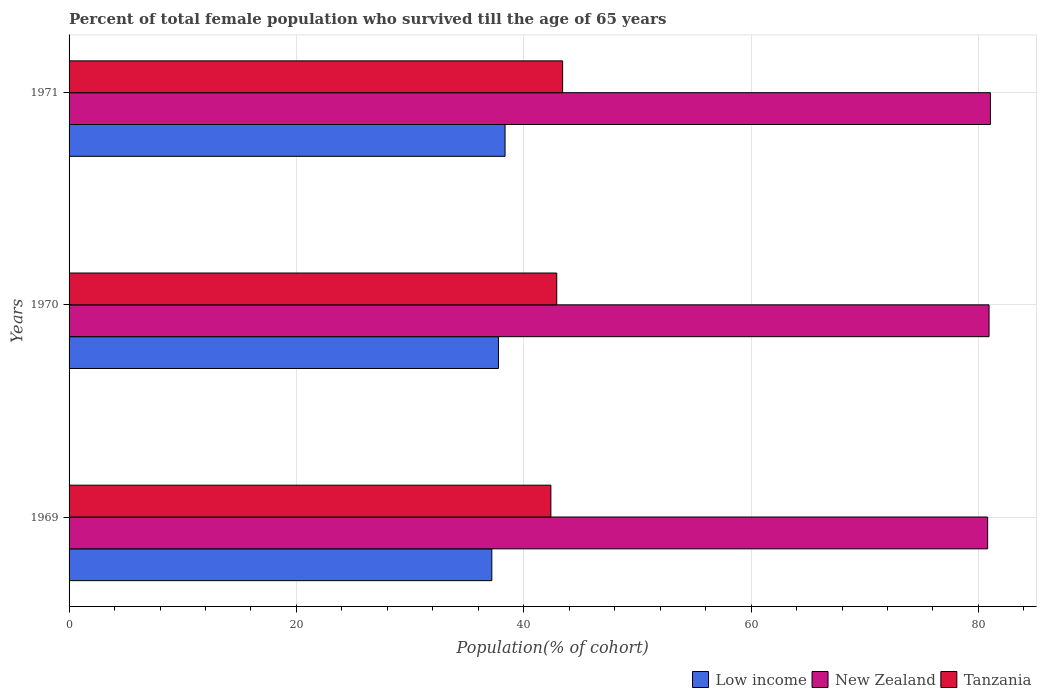How many different coloured bars are there?
Provide a short and direct response. 3. How many groups of bars are there?
Make the answer very short. 3. Are the number of bars per tick equal to the number of legend labels?
Give a very brief answer. Yes. Are the number of bars on each tick of the Y-axis equal?
Offer a terse response. Yes. In how many cases, is the number of bars for a given year not equal to the number of legend labels?
Offer a terse response. 0. What is the percentage of total female population who survived till the age of 65 years in New Zealand in 1969?
Provide a short and direct response. 80.81. Across all years, what is the maximum percentage of total female population who survived till the age of 65 years in Tanzania?
Your response must be concise. 43.42. Across all years, what is the minimum percentage of total female population who survived till the age of 65 years in New Zealand?
Ensure brevity in your answer.  80.81. In which year was the percentage of total female population who survived till the age of 65 years in Low income minimum?
Provide a succinct answer. 1969. What is the total percentage of total female population who survived till the age of 65 years in New Zealand in the graph?
Offer a very short reply. 242.79. What is the difference between the percentage of total female population who survived till the age of 65 years in Low income in 1969 and that in 1970?
Keep it short and to the point. -0.58. What is the difference between the percentage of total female population who survived till the age of 65 years in Tanzania in 1971 and the percentage of total female population who survived till the age of 65 years in New Zealand in 1970?
Your answer should be compact. -37.51. What is the average percentage of total female population who survived till the age of 65 years in Tanzania per year?
Give a very brief answer. 42.9. In the year 1969, what is the difference between the percentage of total female population who survived till the age of 65 years in New Zealand and percentage of total female population who survived till the age of 65 years in Tanzania?
Make the answer very short. 38.43. What is the ratio of the percentage of total female population who survived till the age of 65 years in Low income in 1969 to that in 1971?
Keep it short and to the point. 0.97. Is the percentage of total female population who survived till the age of 65 years in Tanzania in 1970 less than that in 1971?
Keep it short and to the point. Yes. Is the difference between the percentage of total female population who survived till the age of 65 years in New Zealand in 1969 and 1970 greater than the difference between the percentage of total female population who survived till the age of 65 years in Tanzania in 1969 and 1970?
Provide a short and direct response. Yes. What is the difference between the highest and the second highest percentage of total female population who survived till the age of 65 years in New Zealand?
Make the answer very short. 0.12. What is the difference between the highest and the lowest percentage of total female population who survived till the age of 65 years in New Zealand?
Provide a short and direct response. 0.24. Is the sum of the percentage of total female population who survived till the age of 65 years in Low income in 1969 and 1970 greater than the maximum percentage of total female population who survived till the age of 65 years in New Zealand across all years?
Make the answer very short. No. What does the 2nd bar from the top in 1969 represents?
Offer a very short reply. New Zealand. What does the 1st bar from the bottom in 1970 represents?
Keep it short and to the point. Low income. Is it the case that in every year, the sum of the percentage of total female population who survived till the age of 65 years in New Zealand and percentage of total female population who survived till the age of 65 years in Low income is greater than the percentage of total female population who survived till the age of 65 years in Tanzania?
Provide a succinct answer. Yes. How many bars are there?
Your response must be concise. 9. Are all the bars in the graph horizontal?
Provide a succinct answer. Yes. How are the legend labels stacked?
Your answer should be very brief. Horizontal. What is the title of the graph?
Your answer should be very brief. Percent of total female population who survived till the age of 65 years. What is the label or title of the X-axis?
Offer a very short reply. Population(% of cohort). What is the label or title of the Y-axis?
Provide a short and direct response. Years. What is the Population(% of cohort) in Low income in 1969?
Ensure brevity in your answer.  37.19. What is the Population(% of cohort) in New Zealand in 1969?
Provide a succinct answer. 80.81. What is the Population(% of cohort) in Tanzania in 1969?
Ensure brevity in your answer.  42.38. What is the Population(% of cohort) in Low income in 1970?
Give a very brief answer. 37.77. What is the Population(% of cohort) in New Zealand in 1970?
Provide a short and direct response. 80.93. What is the Population(% of cohort) in Tanzania in 1970?
Provide a short and direct response. 42.9. What is the Population(% of cohort) in Low income in 1971?
Your answer should be compact. 38.35. What is the Population(% of cohort) of New Zealand in 1971?
Make the answer very short. 81.05. What is the Population(% of cohort) in Tanzania in 1971?
Offer a terse response. 43.42. Across all years, what is the maximum Population(% of cohort) of Low income?
Give a very brief answer. 38.35. Across all years, what is the maximum Population(% of cohort) of New Zealand?
Your answer should be very brief. 81.05. Across all years, what is the maximum Population(% of cohort) of Tanzania?
Provide a succinct answer. 43.42. Across all years, what is the minimum Population(% of cohort) in Low income?
Your answer should be compact. 37.19. Across all years, what is the minimum Population(% of cohort) in New Zealand?
Your response must be concise. 80.81. Across all years, what is the minimum Population(% of cohort) in Tanzania?
Provide a succinct answer. 42.38. What is the total Population(% of cohort) of Low income in the graph?
Offer a terse response. 113.32. What is the total Population(% of cohort) of New Zealand in the graph?
Keep it short and to the point. 242.79. What is the total Population(% of cohort) of Tanzania in the graph?
Ensure brevity in your answer.  128.71. What is the difference between the Population(% of cohort) of Low income in 1969 and that in 1970?
Keep it short and to the point. -0.58. What is the difference between the Population(% of cohort) in New Zealand in 1969 and that in 1970?
Make the answer very short. -0.12. What is the difference between the Population(% of cohort) in Tanzania in 1969 and that in 1970?
Offer a very short reply. -0.52. What is the difference between the Population(% of cohort) in Low income in 1969 and that in 1971?
Your answer should be compact. -1.16. What is the difference between the Population(% of cohort) in New Zealand in 1969 and that in 1971?
Your answer should be compact. -0.24. What is the difference between the Population(% of cohort) of Tanzania in 1969 and that in 1971?
Provide a short and direct response. -1.03. What is the difference between the Population(% of cohort) of Low income in 1970 and that in 1971?
Keep it short and to the point. -0.58. What is the difference between the Population(% of cohort) in New Zealand in 1970 and that in 1971?
Provide a short and direct response. -0.12. What is the difference between the Population(% of cohort) in Tanzania in 1970 and that in 1971?
Offer a very short reply. -0.52. What is the difference between the Population(% of cohort) of Low income in 1969 and the Population(% of cohort) of New Zealand in 1970?
Your answer should be very brief. -43.74. What is the difference between the Population(% of cohort) of Low income in 1969 and the Population(% of cohort) of Tanzania in 1970?
Ensure brevity in your answer.  -5.71. What is the difference between the Population(% of cohort) of New Zealand in 1969 and the Population(% of cohort) of Tanzania in 1970?
Provide a short and direct response. 37.91. What is the difference between the Population(% of cohort) in Low income in 1969 and the Population(% of cohort) in New Zealand in 1971?
Provide a short and direct response. -43.86. What is the difference between the Population(% of cohort) in Low income in 1969 and the Population(% of cohort) in Tanzania in 1971?
Offer a terse response. -6.23. What is the difference between the Population(% of cohort) in New Zealand in 1969 and the Population(% of cohort) in Tanzania in 1971?
Make the answer very short. 37.39. What is the difference between the Population(% of cohort) in Low income in 1970 and the Population(% of cohort) in New Zealand in 1971?
Your answer should be compact. -43.28. What is the difference between the Population(% of cohort) of Low income in 1970 and the Population(% of cohort) of Tanzania in 1971?
Your answer should be very brief. -5.65. What is the difference between the Population(% of cohort) of New Zealand in 1970 and the Population(% of cohort) of Tanzania in 1971?
Make the answer very short. 37.51. What is the average Population(% of cohort) in Low income per year?
Your response must be concise. 37.77. What is the average Population(% of cohort) in New Zealand per year?
Your response must be concise. 80.93. What is the average Population(% of cohort) of Tanzania per year?
Make the answer very short. 42.9. In the year 1969, what is the difference between the Population(% of cohort) in Low income and Population(% of cohort) in New Zealand?
Offer a very short reply. -43.62. In the year 1969, what is the difference between the Population(% of cohort) in Low income and Population(% of cohort) in Tanzania?
Your response must be concise. -5.19. In the year 1969, what is the difference between the Population(% of cohort) of New Zealand and Population(% of cohort) of Tanzania?
Provide a succinct answer. 38.42. In the year 1970, what is the difference between the Population(% of cohort) in Low income and Population(% of cohort) in New Zealand?
Make the answer very short. -43.16. In the year 1970, what is the difference between the Population(% of cohort) of Low income and Population(% of cohort) of Tanzania?
Provide a short and direct response. -5.13. In the year 1970, what is the difference between the Population(% of cohort) of New Zealand and Population(% of cohort) of Tanzania?
Ensure brevity in your answer.  38.03. In the year 1971, what is the difference between the Population(% of cohort) in Low income and Population(% of cohort) in New Zealand?
Keep it short and to the point. -42.7. In the year 1971, what is the difference between the Population(% of cohort) in Low income and Population(% of cohort) in Tanzania?
Your answer should be very brief. -5.06. In the year 1971, what is the difference between the Population(% of cohort) in New Zealand and Population(% of cohort) in Tanzania?
Provide a short and direct response. 37.63. What is the ratio of the Population(% of cohort) of Low income in 1969 to that in 1970?
Give a very brief answer. 0.98. What is the ratio of the Population(% of cohort) in Tanzania in 1969 to that in 1970?
Offer a very short reply. 0.99. What is the ratio of the Population(% of cohort) of Low income in 1969 to that in 1971?
Your response must be concise. 0.97. What is the ratio of the Population(% of cohort) in New Zealand in 1969 to that in 1971?
Offer a terse response. 1. What is the ratio of the Population(% of cohort) of Tanzania in 1969 to that in 1971?
Offer a very short reply. 0.98. What is the ratio of the Population(% of cohort) of Low income in 1970 to that in 1971?
Provide a succinct answer. 0.98. What is the ratio of the Population(% of cohort) of Tanzania in 1970 to that in 1971?
Give a very brief answer. 0.99. What is the difference between the highest and the second highest Population(% of cohort) of Low income?
Your response must be concise. 0.58. What is the difference between the highest and the second highest Population(% of cohort) in New Zealand?
Make the answer very short. 0.12. What is the difference between the highest and the second highest Population(% of cohort) of Tanzania?
Your response must be concise. 0.52. What is the difference between the highest and the lowest Population(% of cohort) of Low income?
Your response must be concise. 1.16. What is the difference between the highest and the lowest Population(% of cohort) in New Zealand?
Your response must be concise. 0.24. What is the difference between the highest and the lowest Population(% of cohort) in Tanzania?
Offer a very short reply. 1.03. 